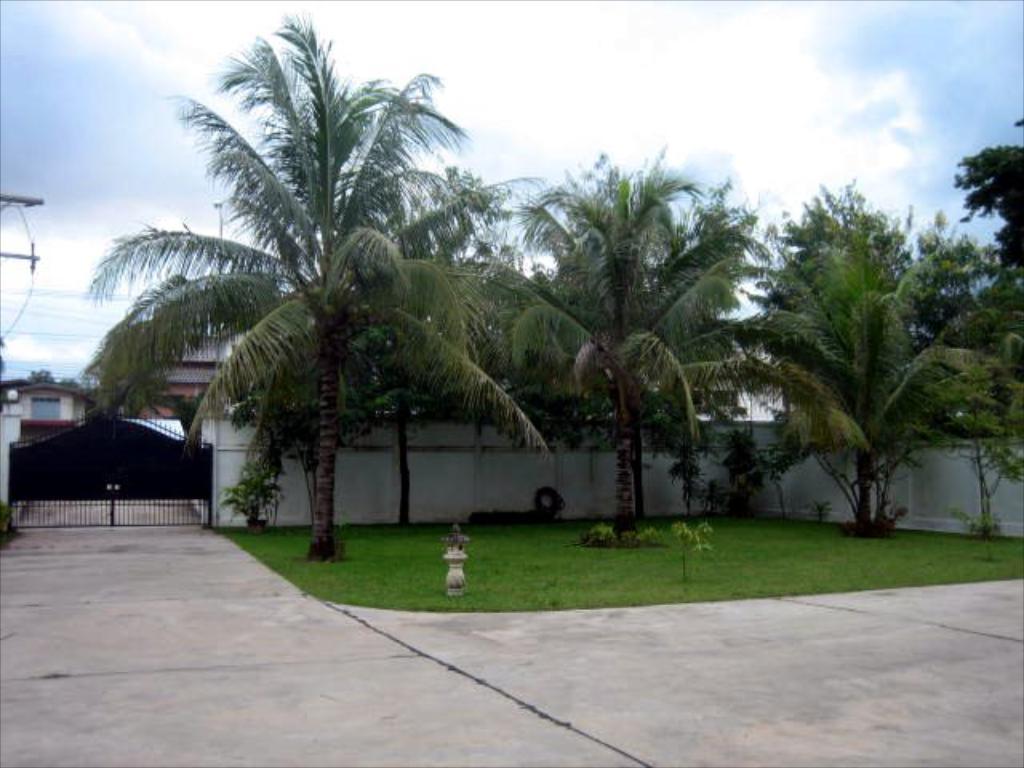Could you give a brief overview of what you see in this image? This is the picture of a place where we have a gate, trees, plants, grass on the floor and also we can see some houses to the other side of the gate. 